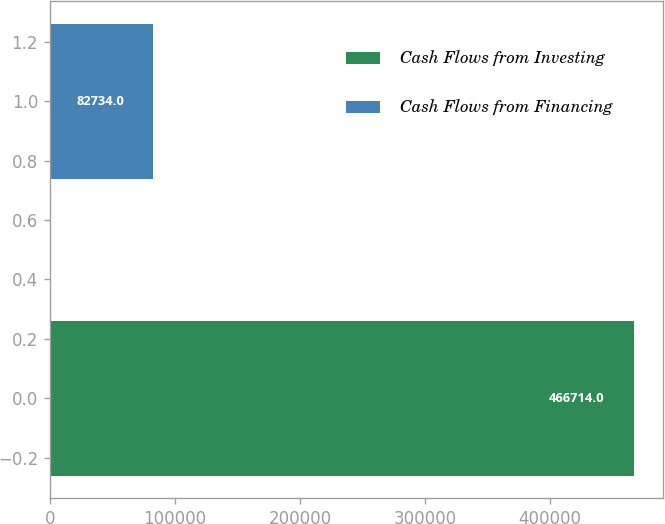<chart> <loc_0><loc_0><loc_500><loc_500><bar_chart><fcel>Cash Flows from Investing<fcel>Cash Flows from Financing<nl><fcel>466714<fcel>82734<nl></chart> 